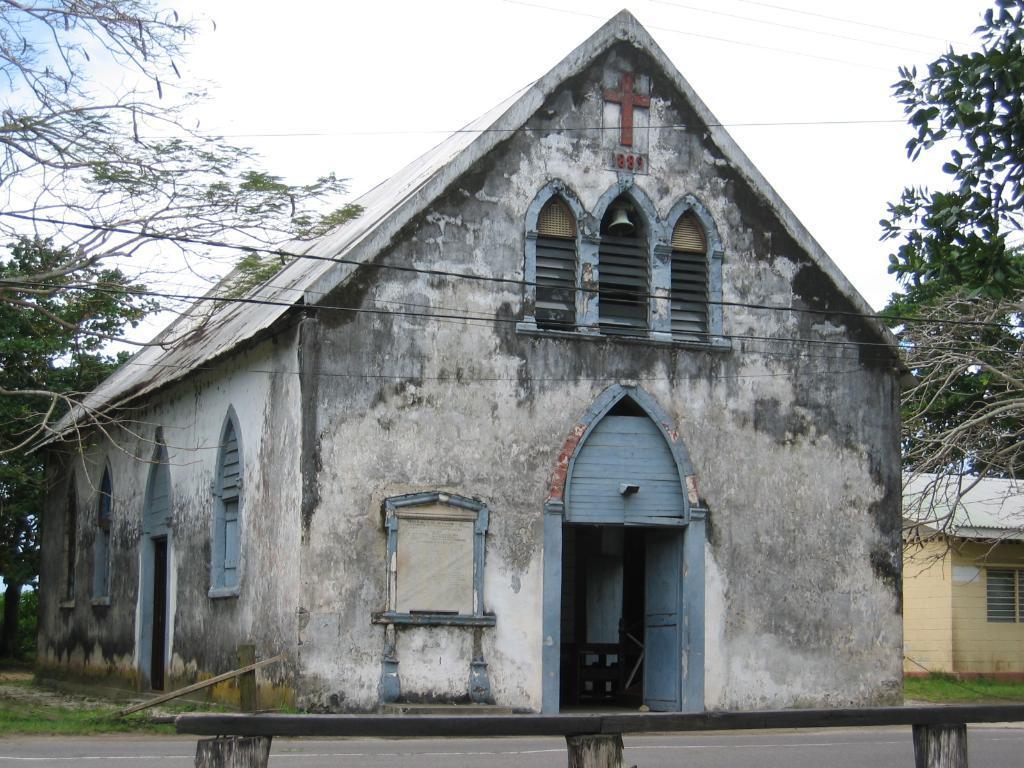How would you summarize this image in a sentence or two? In this image we can see a building with windows, doors and a bell on it. To the right side of the image we can see a building and in the foreground we can see a fence. In the background, we can see a group of trees and sky. 